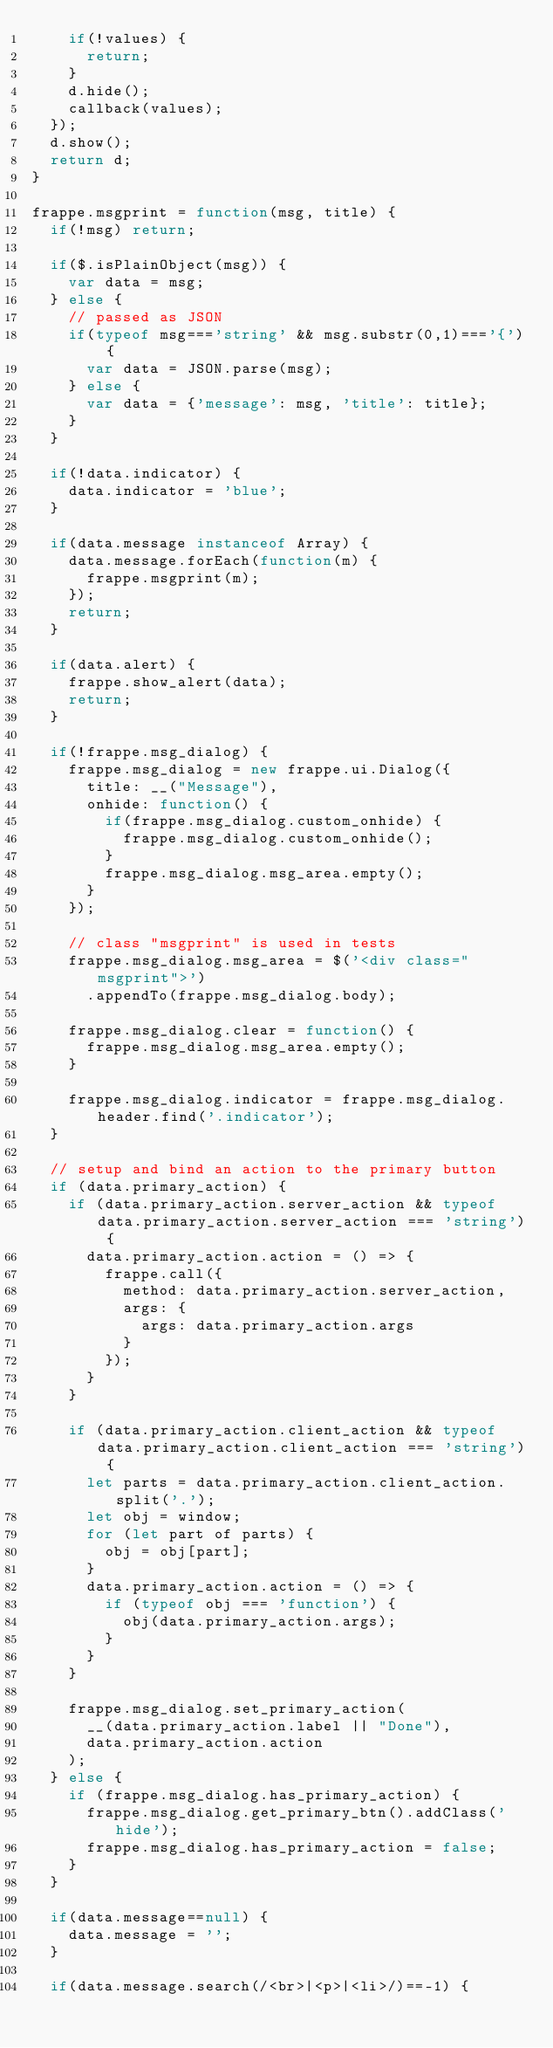Convert code to text. <code><loc_0><loc_0><loc_500><loc_500><_JavaScript_>		if(!values) {
			return;
		}
		d.hide();
		callback(values);
	});
	d.show();
	return d;
}

frappe.msgprint = function(msg, title) {
	if(!msg) return;

	if($.isPlainObject(msg)) {
		var data = msg;
	} else {
		// passed as JSON
		if(typeof msg==='string' && msg.substr(0,1)==='{') {
			var data = JSON.parse(msg);
		} else {
			var data = {'message': msg, 'title': title};
		}
	}

	if(!data.indicator) {
		data.indicator = 'blue';
	}

	if(data.message instanceof Array) {
		data.message.forEach(function(m) {
			frappe.msgprint(m);
		});
		return;
	}

	if(data.alert) {
		frappe.show_alert(data);
		return;
	}

	if(!frappe.msg_dialog) {
		frappe.msg_dialog = new frappe.ui.Dialog({
			title: __("Message"),
			onhide: function() {
				if(frappe.msg_dialog.custom_onhide) {
					frappe.msg_dialog.custom_onhide();
				}
				frappe.msg_dialog.msg_area.empty();
			}
		});

		// class "msgprint" is used in tests
		frappe.msg_dialog.msg_area = $('<div class="msgprint">')
			.appendTo(frappe.msg_dialog.body);

		frappe.msg_dialog.clear = function() {
			frappe.msg_dialog.msg_area.empty();
		}

		frappe.msg_dialog.indicator = frappe.msg_dialog.header.find('.indicator');
	}

	// setup and bind an action to the primary button
	if (data.primary_action) {
		if (data.primary_action.server_action && typeof data.primary_action.server_action === 'string') {
			data.primary_action.action = () => {
				frappe.call({
					method: data.primary_action.server_action,
					args: {
						args: data.primary_action.args
					}
				});
			}
		}

		if (data.primary_action.client_action && typeof data.primary_action.client_action === 'string') {
			let parts = data.primary_action.client_action.split('.');
			let obj = window;
			for (let part of parts) {
				obj = obj[part];
			}
			data.primary_action.action = () => {
				if (typeof obj === 'function') {
					obj(data.primary_action.args);
				}
			}
		}

		frappe.msg_dialog.set_primary_action(
			__(data.primary_action.label || "Done"),
			data.primary_action.action
		);
	} else {
		if (frappe.msg_dialog.has_primary_action) {
			frappe.msg_dialog.get_primary_btn().addClass('hide');
			frappe.msg_dialog.has_primary_action = false;
		}
	}

	if(data.message==null) {
		data.message = '';
	}

	if(data.message.search(/<br>|<p>|<li>/)==-1) {</code> 